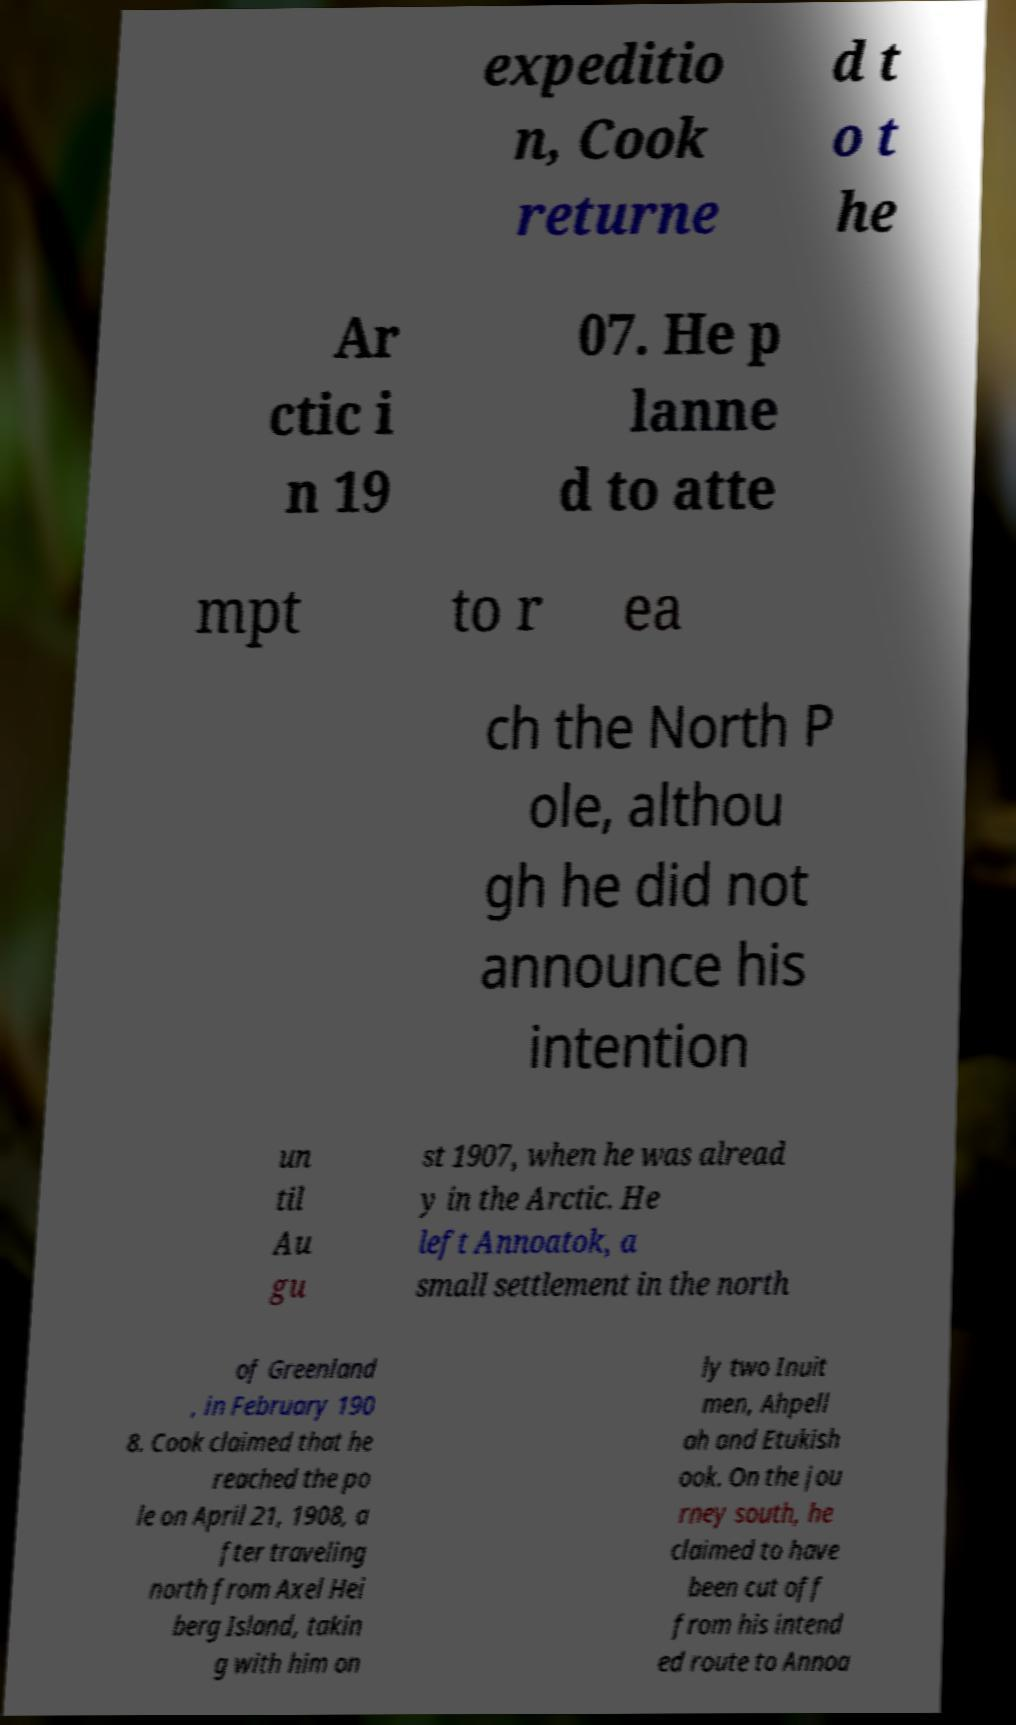Please identify and transcribe the text found in this image. expeditio n, Cook returne d t o t he Ar ctic i n 19 07. He p lanne d to atte mpt to r ea ch the North P ole, althou gh he did not announce his intention un til Au gu st 1907, when he was alread y in the Arctic. He left Annoatok, a small settlement in the north of Greenland , in February 190 8. Cook claimed that he reached the po le on April 21, 1908, a fter traveling north from Axel Hei berg Island, takin g with him on ly two Inuit men, Ahpell ah and Etukish ook. On the jou rney south, he claimed to have been cut off from his intend ed route to Annoa 